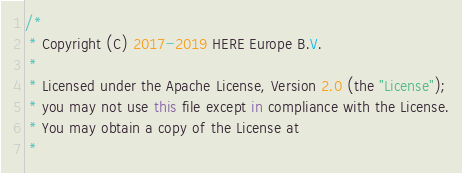<code> <loc_0><loc_0><loc_500><loc_500><_Kotlin_>/*
 * Copyright (C) 2017-2019 HERE Europe B.V.
 *
 * Licensed under the Apache License, Version 2.0 (the "License");
 * you may not use this file except in compliance with the License.
 * You may obtain a copy of the License at
 *</code> 